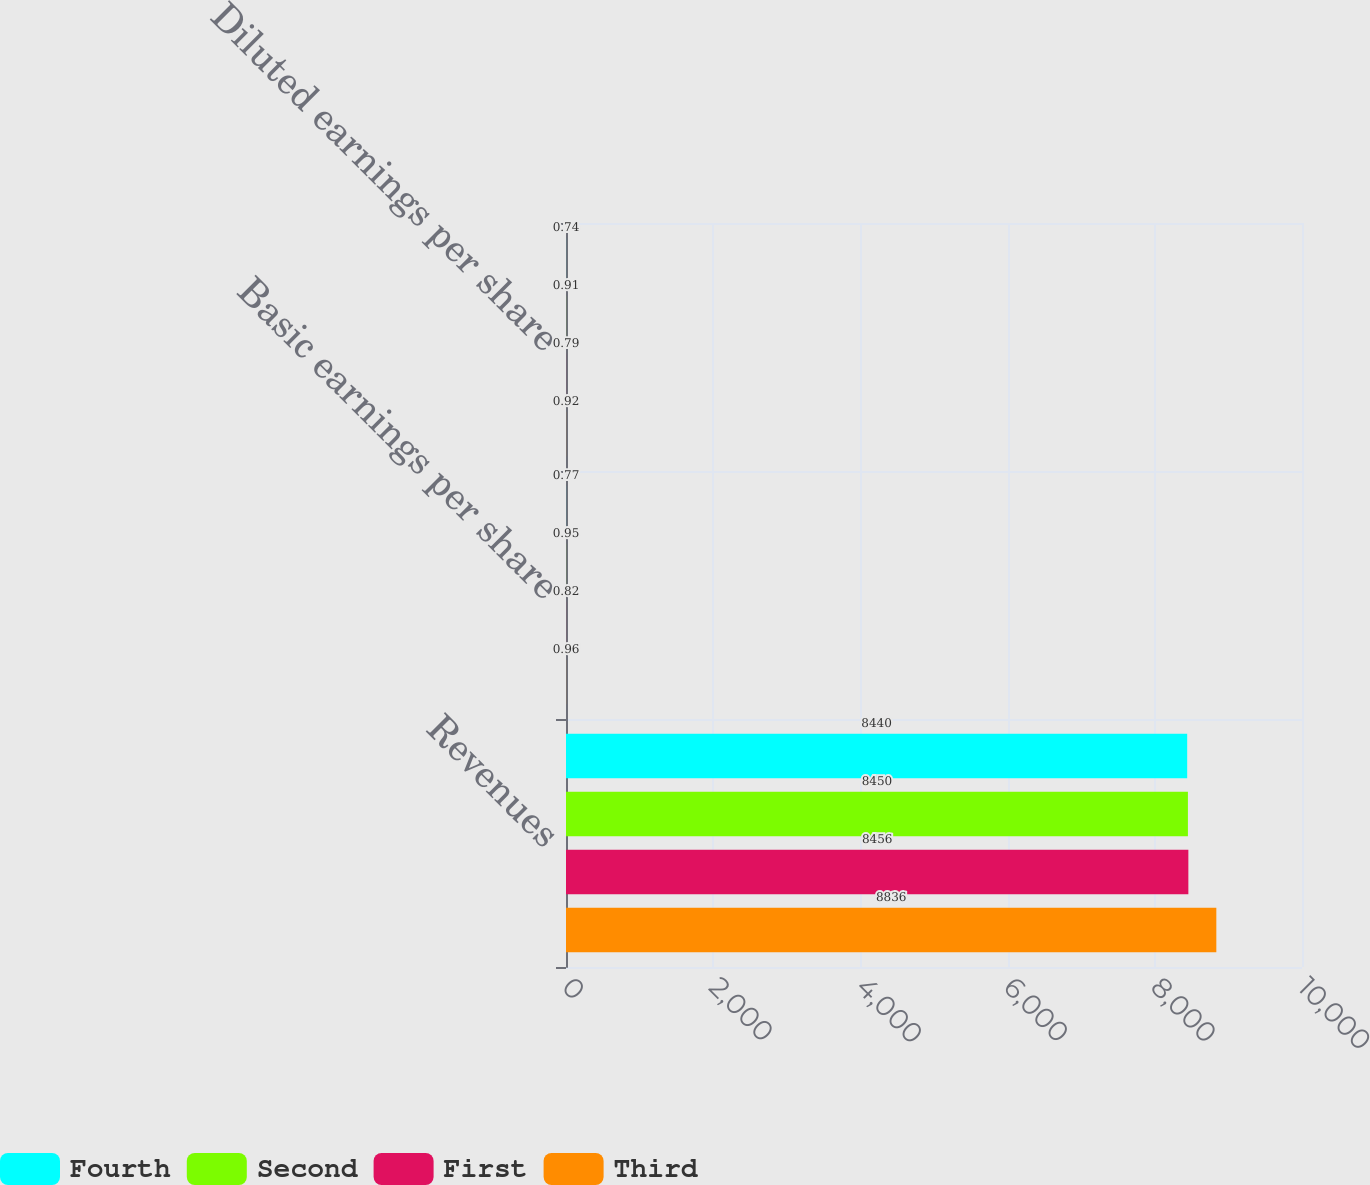<chart> <loc_0><loc_0><loc_500><loc_500><stacked_bar_chart><ecel><fcel>Revenues<fcel>Basic earnings per share<fcel>Diluted earnings per share<nl><fcel>Fourth<fcel>8440<fcel>0.77<fcel>0.74<nl><fcel>Second<fcel>8450<fcel>0.95<fcel>0.91<nl><fcel>First<fcel>8456<fcel>0.82<fcel>0.79<nl><fcel>Third<fcel>8836<fcel>0.96<fcel>0.92<nl></chart> 